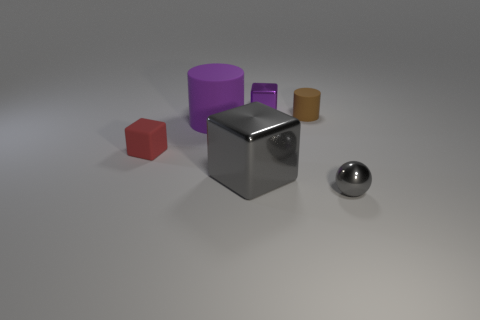Add 2 tiny gray matte blocks. How many objects exist? 8 Subtract all purple cubes. How many cubes are left? 2 Subtract all blue cylinders. How many yellow cubes are left? 0 Subtract all large red rubber objects. Subtract all tiny shiny objects. How many objects are left? 4 Add 1 metal balls. How many metal balls are left? 2 Add 4 gray balls. How many gray balls exist? 5 Subtract all red rubber cubes. How many cubes are left? 2 Subtract 1 red blocks. How many objects are left? 5 Subtract all cylinders. How many objects are left? 4 Subtract 3 cubes. How many cubes are left? 0 